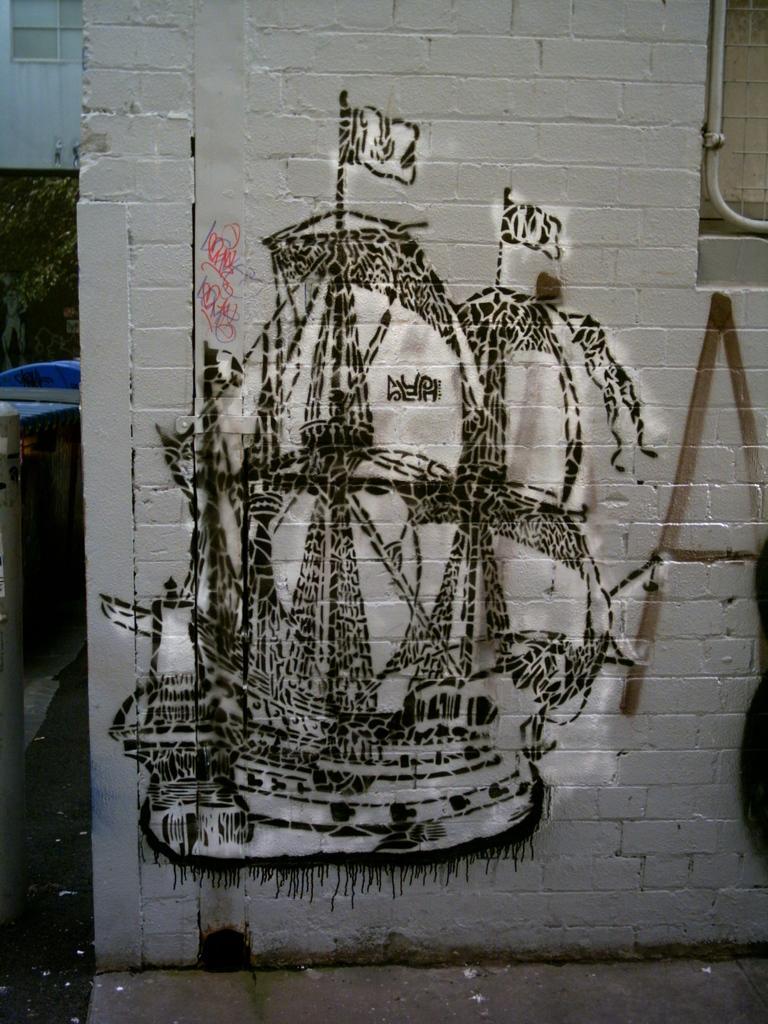Could you give a brief overview of what you see in this image? In this image I can see a white colour wall in the front and on it I can see drawing of a ship. On the left side of this image I can see a blue colour thing. 